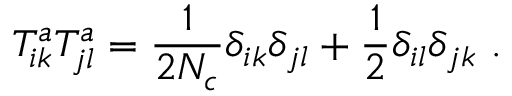<formula> <loc_0><loc_0><loc_500><loc_500>T _ { i k } ^ { a } T _ { j l } ^ { a } = \frac { 1 } { 2 N _ { c } } \delta _ { i k } \delta _ { j l } + \frac { 1 } { 2 } \delta _ { i l } \delta _ { j k } .</formula> 